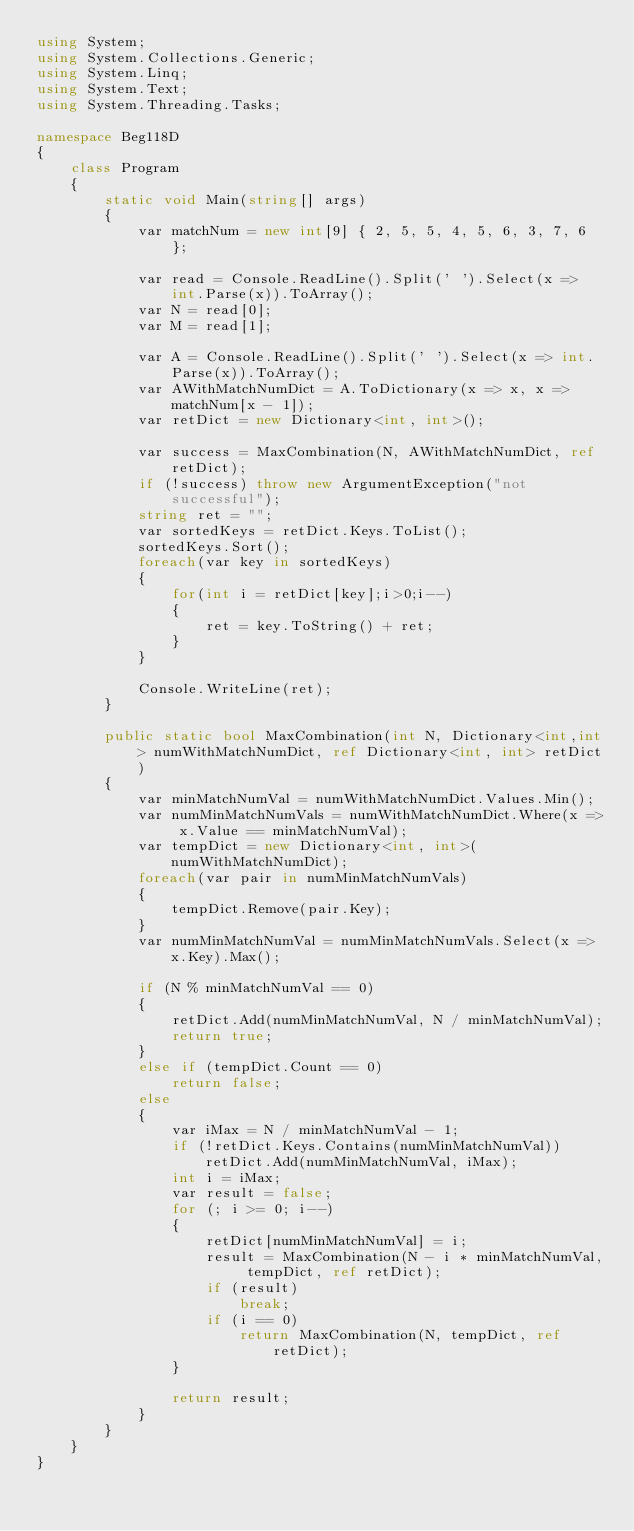<code> <loc_0><loc_0><loc_500><loc_500><_C#_>using System;
using System.Collections.Generic;
using System.Linq;
using System.Text;
using System.Threading.Tasks;

namespace Beg118D
{
    class Program
    {
        static void Main(string[] args)
        {
            var matchNum = new int[9] { 2, 5, 5, 4, 5, 6, 3, 7, 6 };

            var read = Console.ReadLine().Split(' ').Select(x => int.Parse(x)).ToArray();
            var N = read[0];
            var M = read[1];

            var A = Console.ReadLine().Split(' ').Select(x => int.Parse(x)).ToArray();
            var AWithMatchNumDict = A.ToDictionary(x => x, x => matchNum[x - 1]);
            var retDict = new Dictionary<int, int>();

            var success = MaxCombination(N, AWithMatchNumDict, ref retDict);
            if (!success) throw new ArgumentException("not successful");
            string ret = "";
            var sortedKeys = retDict.Keys.ToList();
            sortedKeys.Sort();
            foreach(var key in sortedKeys)
            {
                for(int i = retDict[key];i>0;i--)
                {
                    ret = key.ToString() + ret;
                }
            }

            Console.WriteLine(ret);
        }

        public static bool MaxCombination(int N, Dictionary<int,int> numWithMatchNumDict, ref Dictionary<int, int> retDict)
        {
            var minMatchNumVal = numWithMatchNumDict.Values.Min();
            var numMinMatchNumVals = numWithMatchNumDict.Where(x => x.Value == minMatchNumVal);
            var tempDict = new Dictionary<int, int>(numWithMatchNumDict);
            foreach(var pair in numMinMatchNumVals)
            {
                tempDict.Remove(pair.Key);
            }
            var numMinMatchNumVal = numMinMatchNumVals.Select(x => x.Key).Max();

            if (N % minMatchNumVal == 0)
            {
                retDict.Add(numMinMatchNumVal, N / minMatchNumVal);
                return true;
            }
            else if (tempDict.Count == 0)
                return false;
            else
            {
                var iMax = N / minMatchNumVal - 1;
                if (!retDict.Keys.Contains(numMinMatchNumVal)) retDict.Add(numMinMatchNumVal, iMax);
                int i = iMax;
                var result = false;
                for (; i >= 0; i--)
                {
                    retDict[numMinMatchNumVal] = i;
                    result = MaxCombination(N - i * minMatchNumVal, tempDict, ref retDict);
                    if (result)
                        break;
                    if (i == 0)
                        return MaxCombination(N, tempDict, ref retDict);
                }

                return result;
            }
        }
    }
}
</code> 